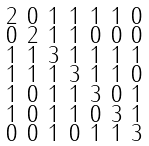Convert formula to latex. <formula><loc_0><loc_0><loc_500><loc_500>\begin{smallmatrix} 2 & 0 & 1 & 1 & 1 & 1 & 0 \\ 0 & 2 & 1 & 1 & 0 & 0 & 0 \\ 1 & 1 & 3 & 1 & 1 & 1 & 1 \\ 1 & 1 & 1 & 3 & 1 & 1 & 0 \\ 1 & 0 & 1 & 1 & 3 & 0 & 1 \\ 1 & 0 & 1 & 1 & 0 & 3 & 1 \\ 0 & 0 & 1 & 0 & 1 & 1 & 3 \end{smallmatrix}</formula> 